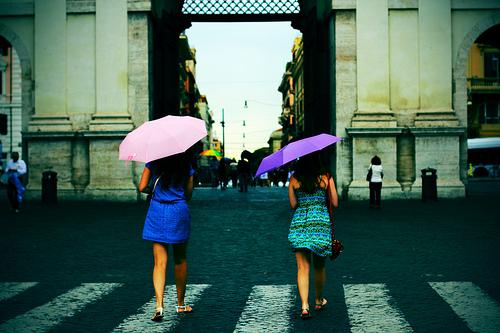Provide a brief description of the architectural elements visible in the image. The image features a large arched gateway, European style buildings, and a city plaza with large stone architectural features. Describe one of the women's hair in the image. One woman has black and long hair. Count the number of umbrellas in this image and their colors. There are three umbrellas: one purple, and two pink. Identify the type of ground shown in the image. The ground is made of rocks with white stripes. In the image, what is a person holding other than an umbrella? A person is holding a red bag. Mention the outfit of the man in the image. The man is wearing jeans and a white shirt. What are two women in the image carrying? Two women are carrying umbrellas. Describe the dresses worn by the females in the picture. The women are wearing blue dresses. What are the two girls doing in the plaza? Two girls are walking in the plaza with umbrellas. Explain what kind of footwear can be seen in the image. Women in the image are wearing white and black sandals. 